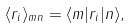<formula> <loc_0><loc_0><loc_500><loc_500>\langle r _ { i } \rangle _ { m n } = \langle m | r _ { i } | n \rangle ,</formula> 